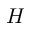<formula> <loc_0><loc_0><loc_500><loc_500>H</formula> 